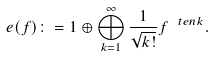<formula> <loc_0><loc_0><loc_500><loc_500>e ( f ) \colon = 1 \oplus \bigoplus _ { k = 1 } ^ { \infty } \frac { 1 } { \sqrt { k ! } } f ^ { \ t e n k } .</formula> 